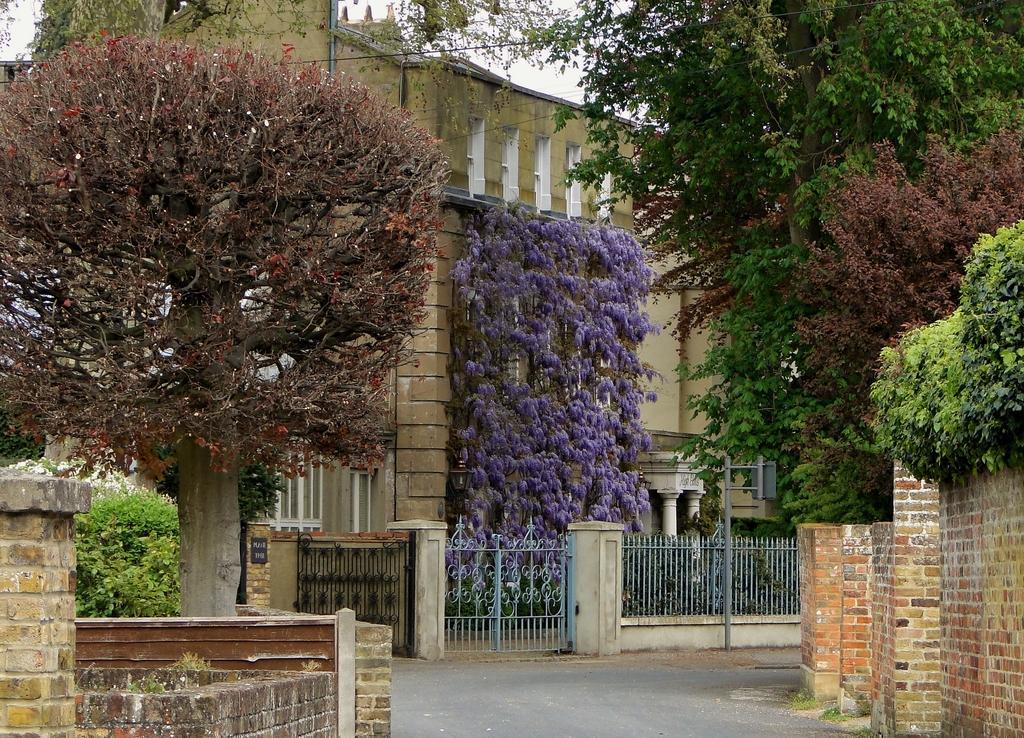How would you summarize this image in a sentence or two? In this image we can see a building, trees, pole, gates, name board, plants and other objects. In the background of the image there is the sky. On the left side of the image there is the wall, grass and other objects. On the right side of the image there is the wall, trees and other objects. At the bottom of the image there is the road. 